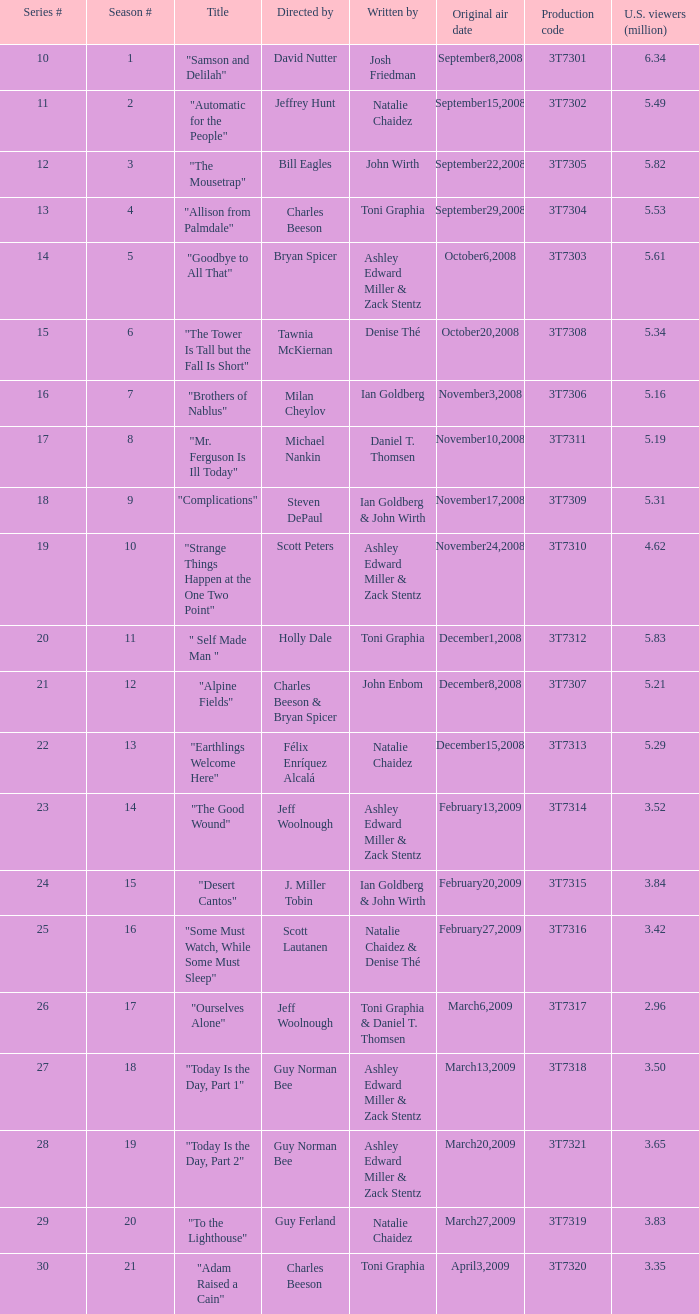Which episode number garnered 24.0. 